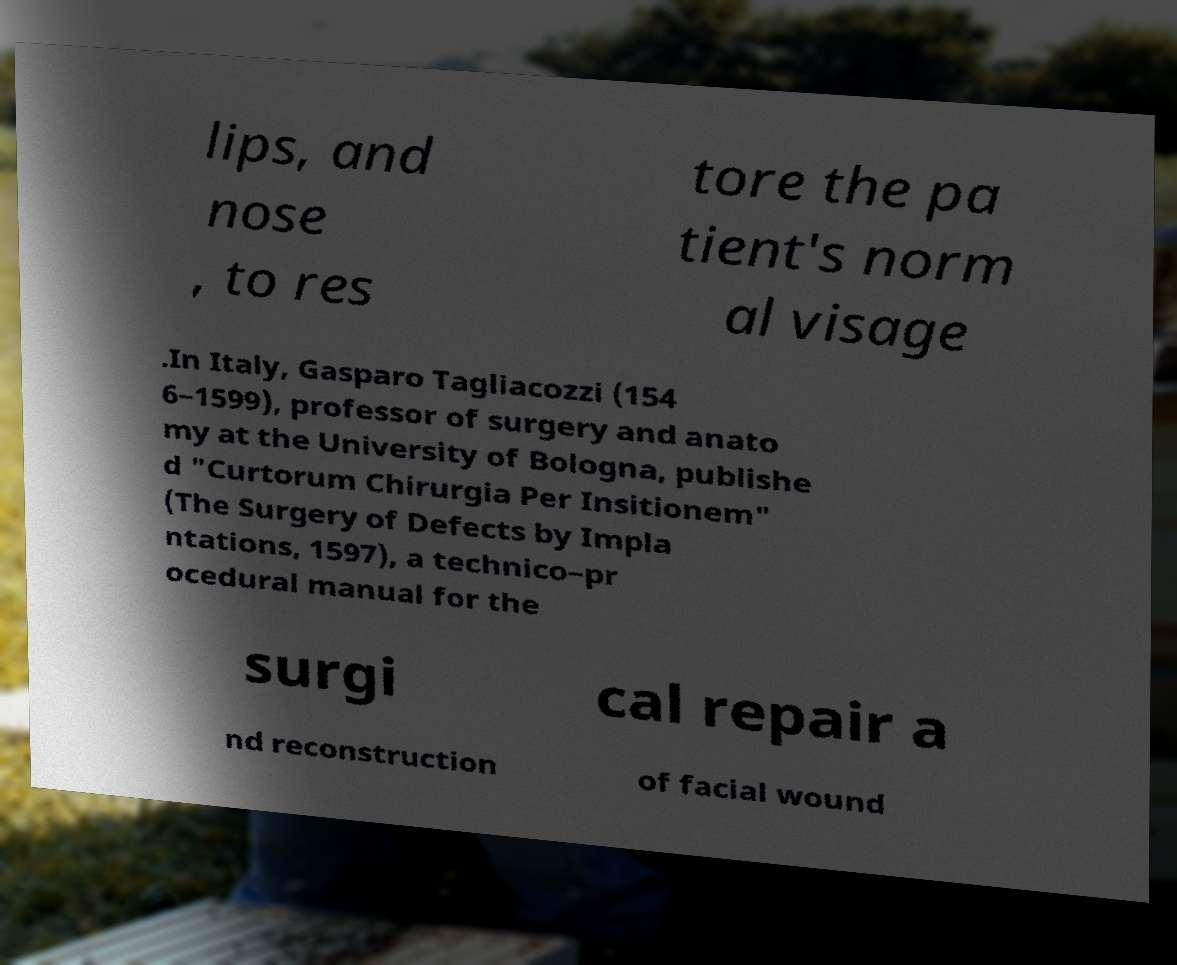Could you extract and type out the text from this image? lips, and nose , to res tore the pa tient's norm al visage .In Italy, Gasparo Tagliacozzi (154 6–1599), professor of surgery and anato my at the University of Bologna, publishe d "Curtorum Chirurgia Per Insitionem" (The Surgery of Defects by Impla ntations, 1597), a technico–pr ocedural manual for the surgi cal repair a nd reconstruction of facial wound 